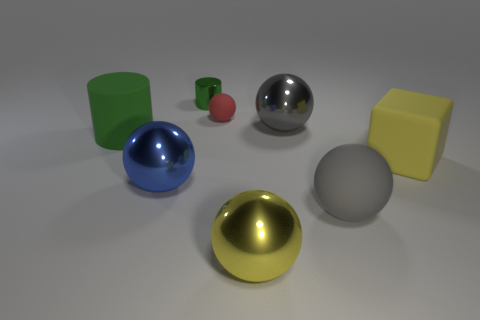What number of big objects have the same material as the yellow sphere? In the image, there are two large objects that share the same glossy material as the yellow sphere: the blue sphere and the silver sphere. Both exhibit a reflective surface similar to that of the yellow sphere, indicating they are likely made of the same or similar materials. 